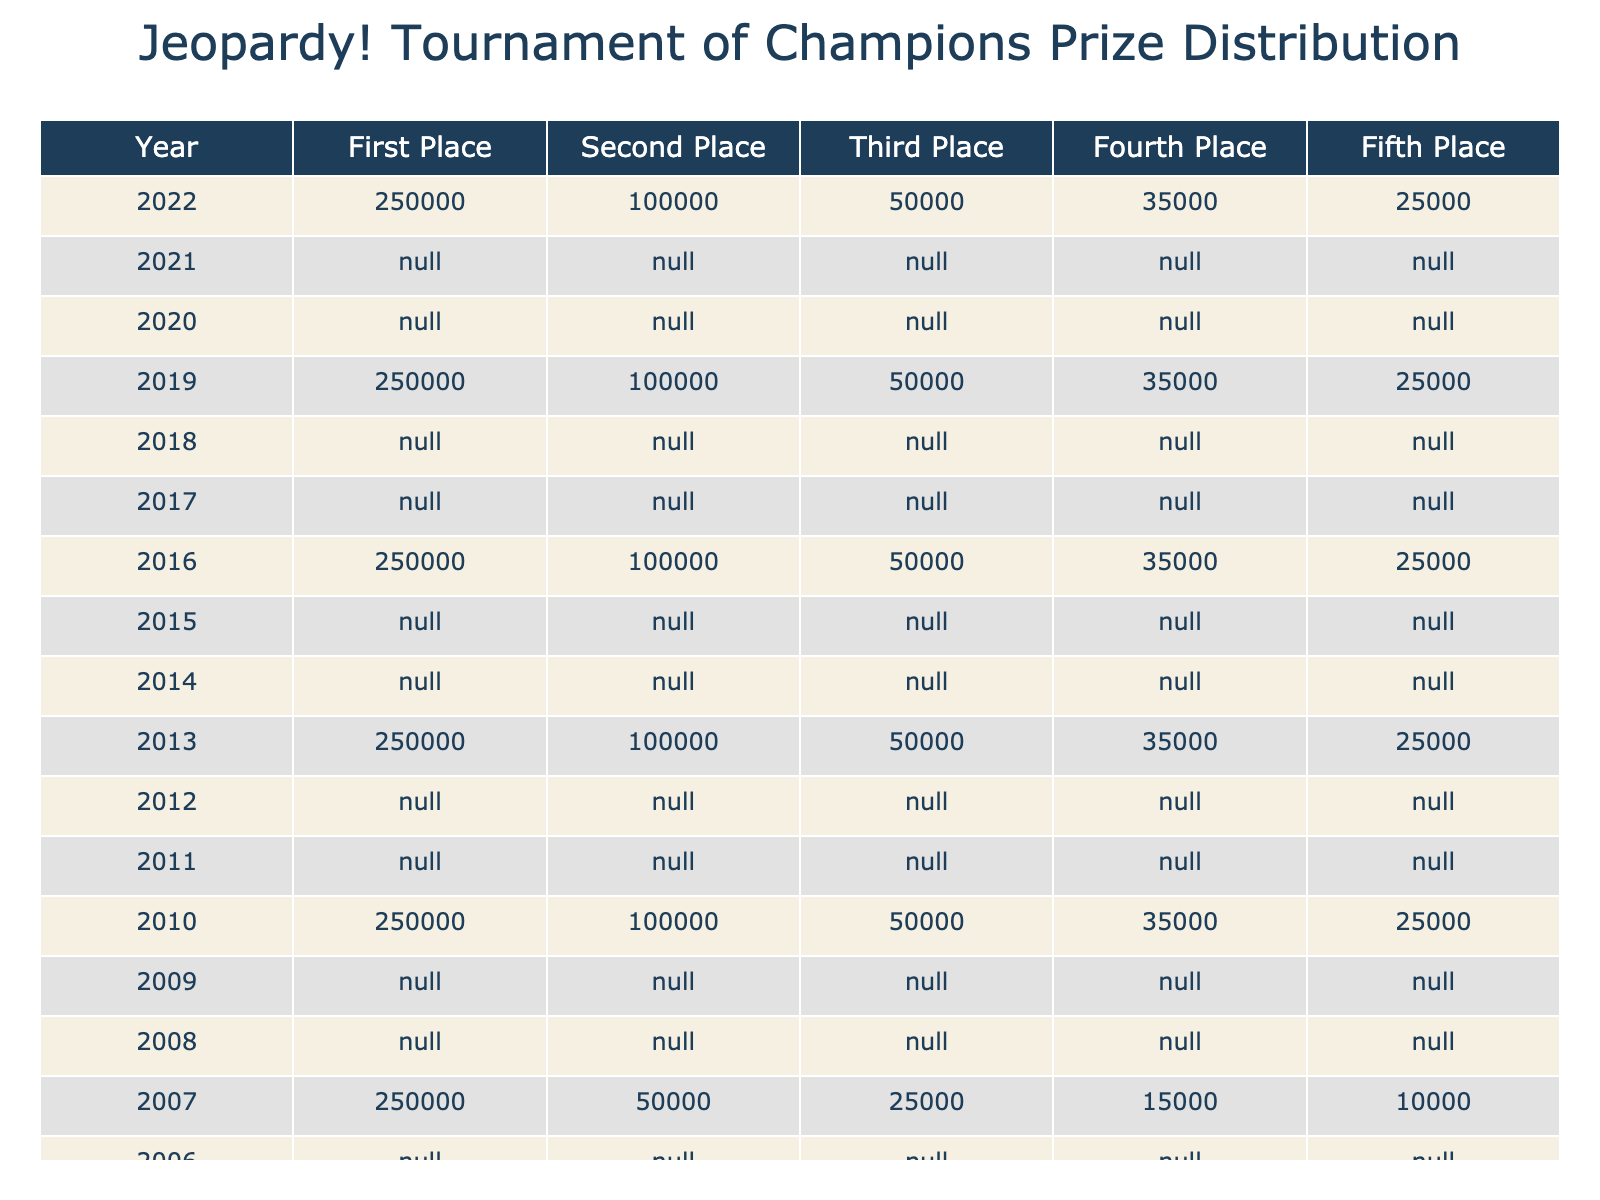What was the prize for first place in the 2022 Tournament of Champions? The table shows that the prize for first place in 2022 was listed directly in the first column under the "First Place" heading. The value is 250,000.
Answer: 250,000 How much more did the first place winner earn compared to the fifth place winner in 2021? For the year 2021, the first place prize is 250,000 while the fifth place prize is 25,000. The difference is calculated as 250,000 - 25,000 = 225,000.
Answer: 225,000 Is the prize amount for third place the same in every year listed in the table? By observing the table, the prize for third place from 2006 to 2022 consistently remains 50,000. Thus, the statement is true.
Answer: Yes What is the average prize for second place from 2006 to 2022? The values for second place from 2006 to 2022 are 50,000 for 2006-2009 and 100,000 for 2010-2022. The sum of these values is (50,000 * 4) + (100,000 * 13) = 200,000 + 1,300,000 = 1,500,000. There are 17 total years, so the average is 1,500,000 / 17 ≈ 88,235.29.
Answer: 88,235.29 What were the total prizes given to all participants in 2015? The total prize money for 2015 can be calculated by adding all the places together: 250,000 (first) + 100,000 (second) + 50,000 (third) + 35,000 (fourth) + 25,000 (fifth) = 250,000 + 100,000 + 50,000 + 35,000 + 25,000 = 460,000.
Answer: 460,000 In how many years did the first place prize remain unchanged? The first place prize of 250,000 remained the same for the years listed from 2006 to 2022, which is 17 years in total. Therefore, the prize was unchanged for all these years.
Answer: 17 years What is the difference in the total prize amounts for fourth place between 2018 and 2022? In 2018, the fourth place prize was 35,000, while in 2022 it was also 35,000. The difference is calculated as 35,000 - 35,000 = 0, indicating there was no change.
Answer: 0 Which year had the lowest prize for third place, and what was that amount? The year with the lowest prize for third place can be identified by checking the values from the years. The table shows that from 2006 to 2018, the third place prize was 50,000 and dropped to 25,000 in 2008 and 2007. Therefore, the lowest value is 25,000 in 2008 and 2007.
Answer: 2007 and 2008, 25,000 What is the trend of prize amounts for the first place across the years? The first place prize remained constant at 250,000 from 2006 to 2022, except for the years 2008 and 2007 when it was not applicable. The trend indicates stability without change for the majority of years.
Answer: No change, remains stable at 250,000 What can be inferred about the fourth place prize before and after 2008? Before 2008, the fourth place prize was consistent at 35,000 (from 2006 to 2015), while it decreased to 15,000 in 2008 and then increased again to 35,000 from 2009 onwards. This change indicates fluctuation during those years.
Answer: Fluctuated, decreased to 15,000 in 2008, then increased back to 35,000 from 2009 